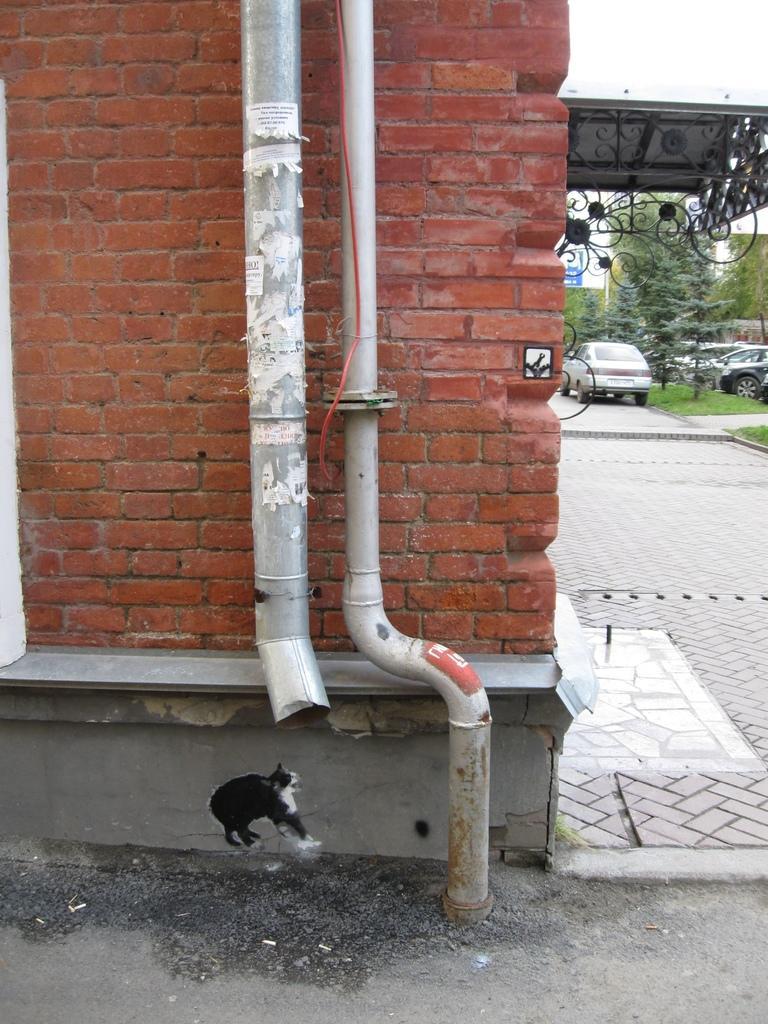In one or two sentences, can you explain what this image depicts? In this image there is a building with red bricks, and there are a few pipes hanging on the wall. On the right side of the image there are a few vehicles parked and there are trees, there is a board with some text. 